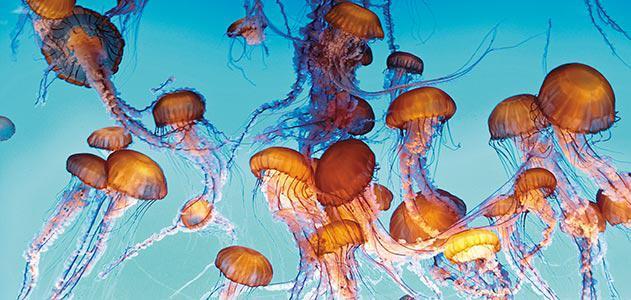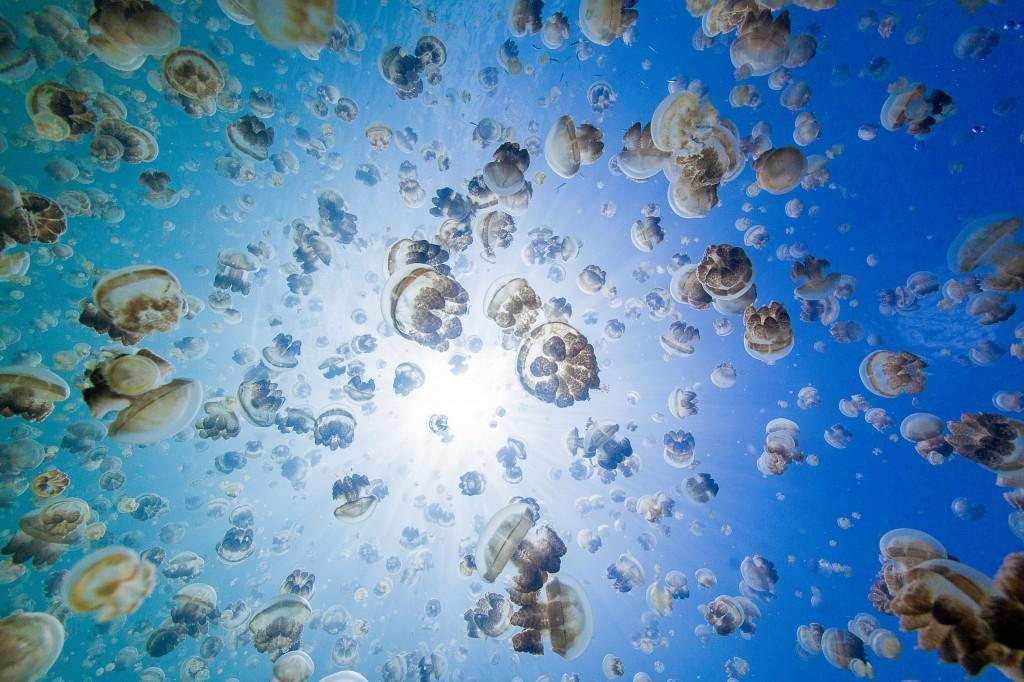The first image is the image on the left, the second image is the image on the right. For the images shown, is this caption "Each image includes at least six orange jellyfish with long tendrils." true? Answer yes or no. No. The first image is the image on the left, the second image is the image on the right. Examine the images to the left and right. Is the description "There are deep red jellyfish and another with shadows of people" accurate? Answer yes or no. No. 